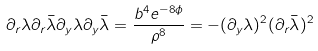<formula> <loc_0><loc_0><loc_500><loc_500>\partial _ { r } \lambda \partial _ { r } \bar { \lambda } \partial _ { y } \lambda \partial _ { y } \bar { \lambda } = \frac { b ^ { 4 } e ^ { - 8 \phi } } { \rho ^ { 8 } } = - ( \partial _ { y } \lambda ) ^ { 2 } ( \partial _ { r } \bar { \lambda } ) ^ { 2 }</formula> 